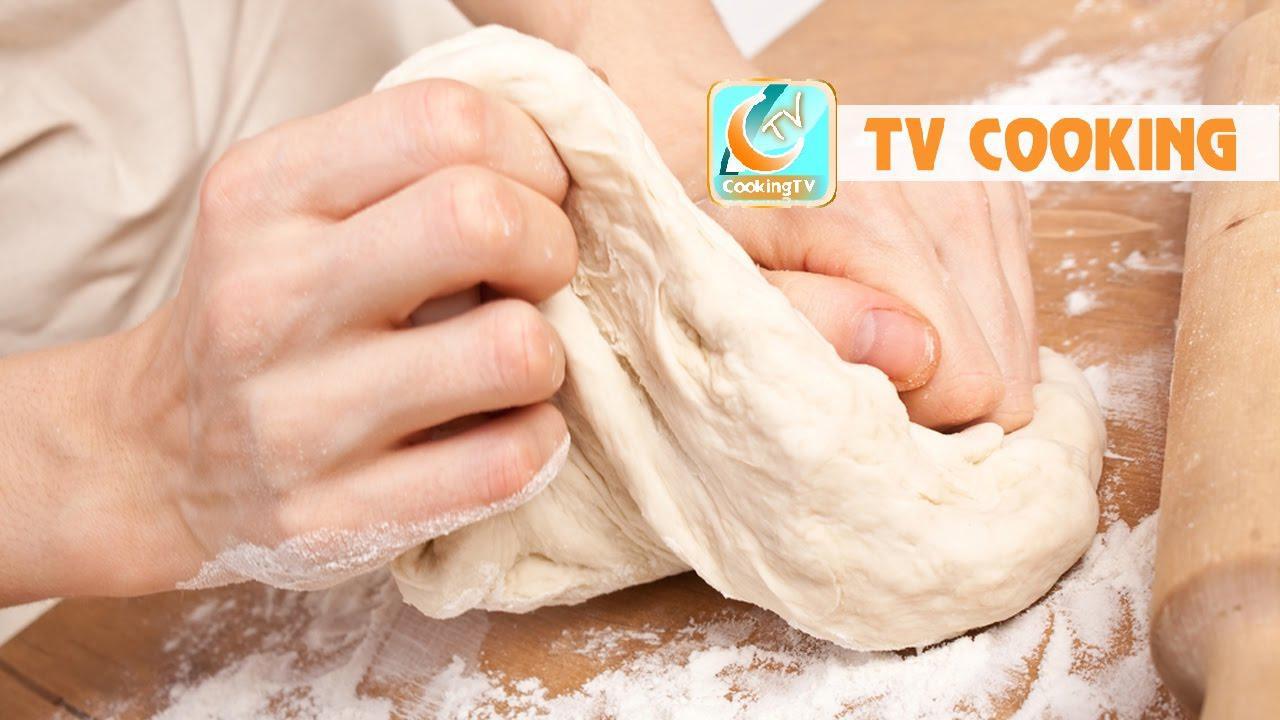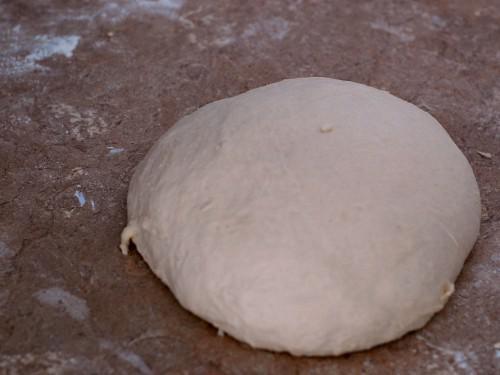The first image is the image on the left, the second image is the image on the right. Examine the images to the left and right. Is the description "There are three hands visible." accurate? Answer yes or no. No. The first image is the image on the left, the second image is the image on the right. Analyze the images presented: Is the assertion "The heel of a hand is punching down a ball of dough on a floured surface in the right image." valid? Answer yes or no. No. 